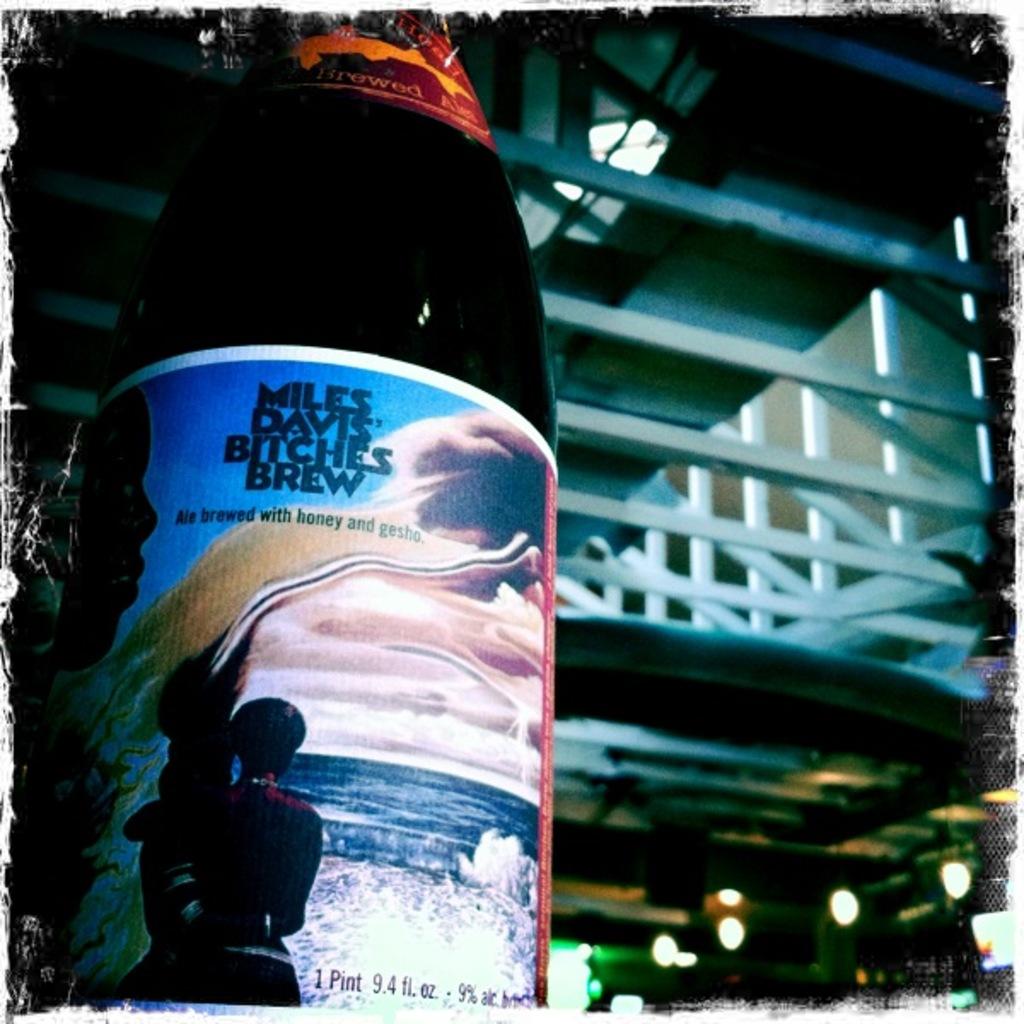Who's brew is this?
Offer a very short reply. Miles davis bitches brew. How much beer is in this container?
Offer a very short reply. 1 pint. 